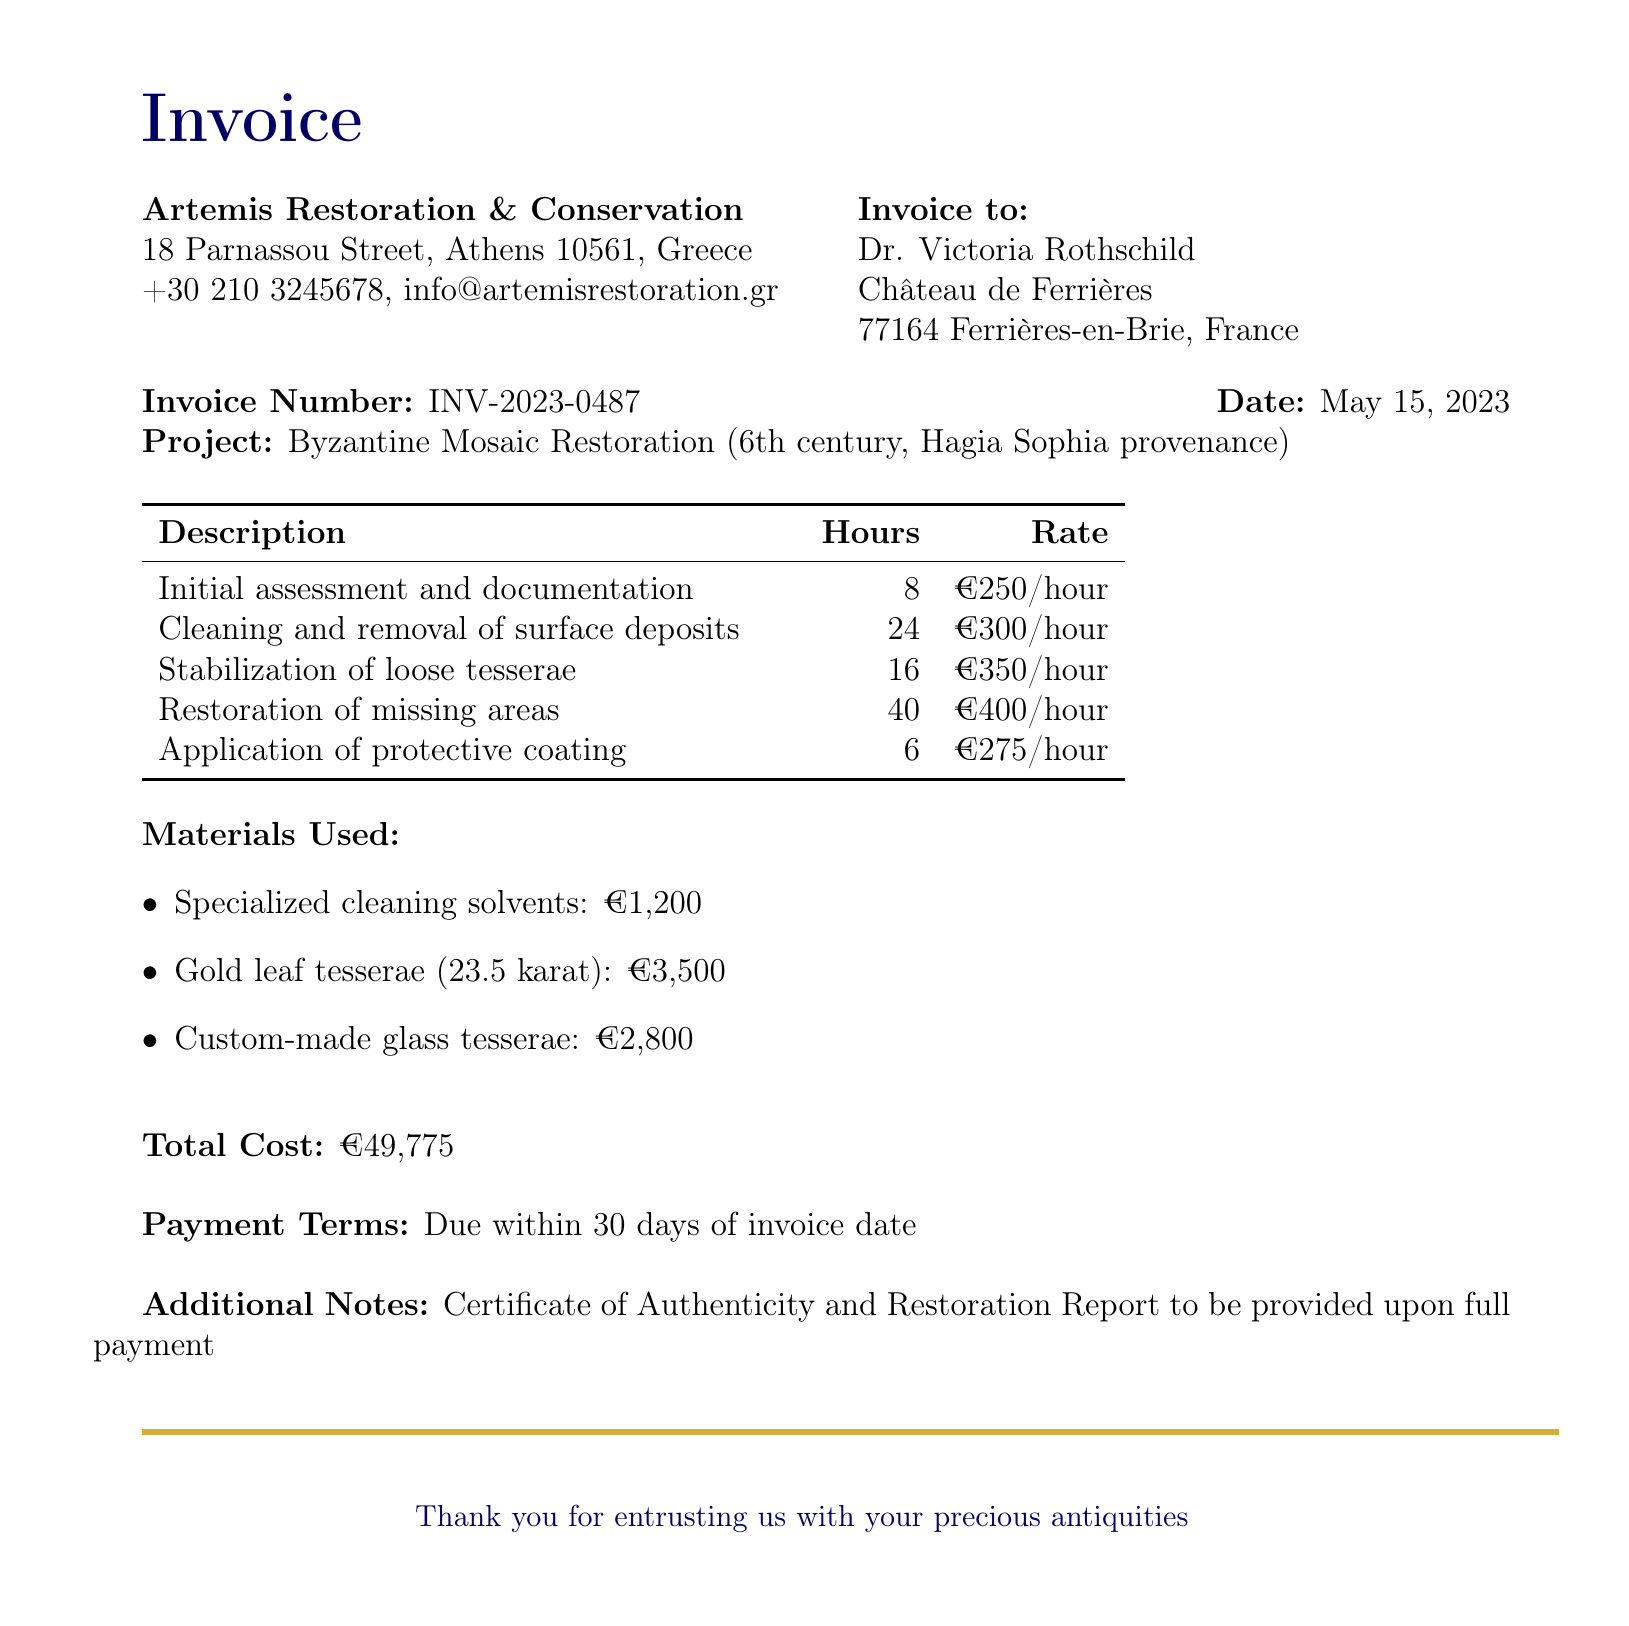What is the name of the restoration company? The document states the name of the company providing restoration services.
Answer: Artemis Restoration & Conservation What is the address of the client? The client’s address is mentioned in the document as part of the client information.
Answer: Château de Ferrières, 77164 Ferrières-en-Brie, France When was the invoice issued? The date of the invoice is explicitly mentioned in the document.
Answer: May 15, 2023 What is the total cost of the services rendered? The total cost is summarized at the end of the document.
Answer: €49,775 How many hours were spent on cleaning and removal of surface deposits? This information is provided in the breakdown of services rendered.
Answer: 24 What is the payment term for the invoice? The payment terms are specified in the document.
Answer: Due within 30 days of invoice date What project is this invoice related to? The project related to the invoice is clearly stated in the details section.
Answer: Byzantine Mosaic Restoration (6th century, Hagia Sophia provenance) What item was the most expensive material used? The materials used are listed with their costs, allowing for identification of the most expensive item.
Answer: Gold leaf tesserae (23.5 karat) What will be provided upon full payment? The document mentions what will be provided after full payment is made.
Answer: Certificate of Authenticity and Restoration Report 